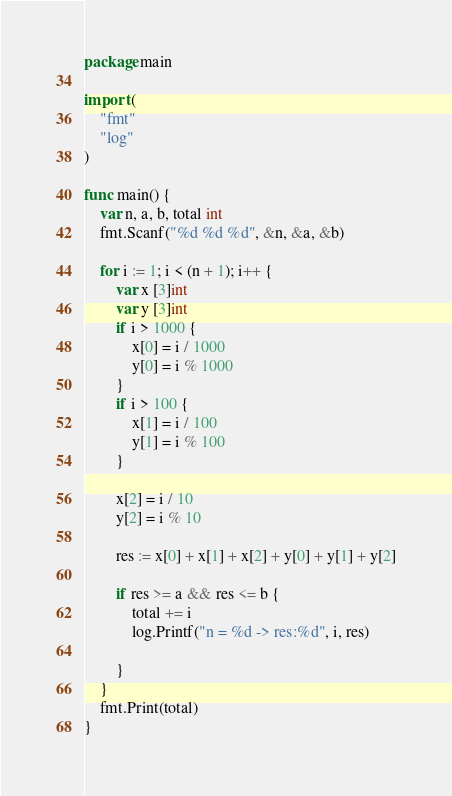<code> <loc_0><loc_0><loc_500><loc_500><_Go_>package main

import (
	"fmt"
	"log"
)

func main() {
	var n, a, b, total int
	fmt.Scanf("%d %d %d", &n, &a, &b)

	for i := 1; i < (n + 1); i++ {
		var x [3]int
		var y [3]int
		if i > 1000 {
			x[0] = i / 1000
			y[0] = i % 1000
		}
		if i > 100 {
			x[1] = i / 100
			y[1] = i % 100
		}

		x[2] = i / 10
		y[2] = i % 10

		res := x[0] + x[1] + x[2] + y[0] + y[1] + y[2]

		if res >= a && res <= b {
			total += i
			log.Printf("n = %d -> res:%d", i, res)

		}
	}
	fmt.Print(total)
}
</code> 